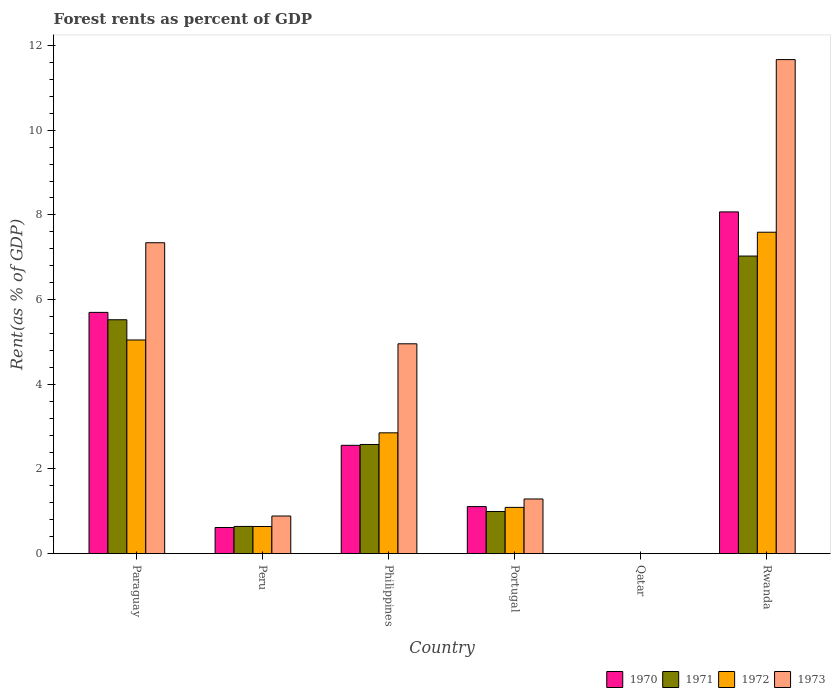How many different coloured bars are there?
Provide a succinct answer. 4. How many groups of bars are there?
Your response must be concise. 6. How many bars are there on the 4th tick from the right?
Provide a short and direct response. 4. What is the label of the 1st group of bars from the left?
Offer a very short reply. Paraguay. What is the forest rent in 1970 in Philippines?
Your answer should be very brief. 2.56. Across all countries, what is the maximum forest rent in 1973?
Keep it short and to the point. 11.67. Across all countries, what is the minimum forest rent in 1970?
Make the answer very short. 0. In which country was the forest rent in 1970 maximum?
Ensure brevity in your answer.  Rwanda. In which country was the forest rent in 1973 minimum?
Keep it short and to the point. Qatar. What is the total forest rent in 1970 in the graph?
Provide a short and direct response. 18.06. What is the difference between the forest rent in 1971 in Portugal and that in Rwanda?
Keep it short and to the point. -6.03. What is the difference between the forest rent in 1970 in Paraguay and the forest rent in 1973 in Rwanda?
Ensure brevity in your answer.  -5.97. What is the average forest rent in 1973 per country?
Keep it short and to the point. 4.36. What is the difference between the forest rent of/in 1970 and forest rent of/in 1973 in Philippines?
Offer a very short reply. -2.4. In how many countries, is the forest rent in 1972 greater than 6.8 %?
Give a very brief answer. 1. What is the ratio of the forest rent in 1972 in Philippines to that in Rwanda?
Ensure brevity in your answer.  0.38. What is the difference between the highest and the second highest forest rent in 1972?
Offer a terse response. -2.19. What is the difference between the highest and the lowest forest rent in 1970?
Provide a short and direct response. 8.07. What does the 3rd bar from the left in Rwanda represents?
Keep it short and to the point. 1972. What does the 4th bar from the right in Paraguay represents?
Provide a succinct answer. 1970. Are all the bars in the graph horizontal?
Keep it short and to the point. No. Are the values on the major ticks of Y-axis written in scientific E-notation?
Give a very brief answer. No. How many legend labels are there?
Offer a terse response. 4. What is the title of the graph?
Your answer should be compact. Forest rents as percent of GDP. What is the label or title of the Y-axis?
Give a very brief answer. Rent(as % of GDP). What is the Rent(as % of GDP) of 1970 in Paraguay?
Offer a terse response. 5.7. What is the Rent(as % of GDP) in 1971 in Paraguay?
Give a very brief answer. 5.52. What is the Rent(as % of GDP) of 1972 in Paraguay?
Make the answer very short. 5.05. What is the Rent(as % of GDP) in 1973 in Paraguay?
Your answer should be very brief. 7.34. What is the Rent(as % of GDP) of 1970 in Peru?
Ensure brevity in your answer.  0.62. What is the Rent(as % of GDP) in 1971 in Peru?
Provide a succinct answer. 0.64. What is the Rent(as % of GDP) of 1972 in Peru?
Keep it short and to the point. 0.64. What is the Rent(as % of GDP) of 1973 in Peru?
Your answer should be very brief. 0.89. What is the Rent(as % of GDP) in 1970 in Philippines?
Provide a succinct answer. 2.56. What is the Rent(as % of GDP) of 1971 in Philippines?
Provide a succinct answer. 2.58. What is the Rent(as % of GDP) of 1972 in Philippines?
Keep it short and to the point. 2.85. What is the Rent(as % of GDP) in 1973 in Philippines?
Offer a very short reply. 4.96. What is the Rent(as % of GDP) of 1970 in Portugal?
Offer a very short reply. 1.11. What is the Rent(as % of GDP) in 1971 in Portugal?
Your answer should be very brief. 1. What is the Rent(as % of GDP) in 1972 in Portugal?
Keep it short and to the point. 1.09. What is the Rent(as % of GDP) in 1973 in Portugal?
Provide a succinct answer. 1.29. What is the Rent(as % of GDP) of 1970 in Qatar?
Offer a very short reply. 0. What is the Rent(as % of GDP) in 1971 in Qatar?
Keep it short and to the point. 0. What is the Rent(as % of GDP) of 1972 in Qatar?
Provide a short and direct response. 0. What is the Rent(as % of GDP) of 1973 in Qatar?
Your answer should be compact. 0. What is the Rent(as % of GDP) in 1970 in Rwanda?
Provide a succinct answer. 8.07. What is the Rent(as % of GDP) of 1971 in Rwanda?
Provide a short and direct response. 7.03. What is the Rent(as % of GDP) of 1972 in Rwanda?
Keep it short and to the point. 7.59. What is the Rent(as % of GDP) in 1973 in Rwanda?
Provide a succinct answer. 11.67. Across all countries, what is the maximum Rent(as % of GDP) of 1970?
Give a very brief answer. 8.07. Across all countries, what is the maximum Rent(as % of GDP) of 1971?
Provide a short and direct response. 7.03. Across all countries, what is the maximum Rent(as % of GDP) of 1972?
Offer a very short reply. 7.59. Across all countries, what is the maximum Rent(as % of GDP) of 1973?
Make the answer very short. 11.67. Across all countries, what is the minimum Rent(as % of GDP) of 1970?
Give a very brief answer. 0. Across all countries, what is the minimum Rent(as % of GDP) of 1971?
Provide a succinct answer. 0. Across all countries, what is the minimum Rent(as % of GDP) of 1972?
Your response must be concise. 0. Across all countries, what is the minimum Rent(as % of GDP) of 1973?
Offer a terse response. 0. What is the total Rent(as % of GDP) of 1970 in the graph?
Your answer should be compact. 18.06. What is the total Rent(as % of GDP) of 1971 in the graph?
Ensure brevity in your answer.  16.77. What is the total Rent(as % of GDP) of 1972 in the graph?
Offer a very short reply. 17.23. What is the total Rent(as % of GDP) in 1973 in the graph?
Your answer should be compact. 26.15. What is the difference between the Rent(as % of GDP) in 1970 in Paraguay and that in Peru?
Provide a short and direct response. 5.08. What is the difference between the Rent(as % of GDP) in 1971 in Paraguay and that in Peru?
Your response must be concise. 4.88. What is the difference between the Rent(as % of GDP) in 1972 in Paraguay and that in Peru?
Offer a very short reply. 4.41. What is the difference between the Rent(as % of GDP) in 1973 in Paraguay and that in Peru?
Make the answer very short. 6.45. What is the difference between the Rent(as % of GDP) in 1970 in Paraguay and that in Philippines?
Provide a short and direct response. 3.14. What is the difference between the Rent(as % of GDP) in 1971 in Paraguay and that in Philippines?
Provide a short and direct response. 2.95. What is the difference between the Rent(as % of GDP) in 1972 in Paraguay and that in Philippines?
Offer a terse response. 2.19. What is the difference between the Rent(as % of GDP) in 1973 in Paraguay and that in Philippines?
Your answer should be very brief. 2.39. What is the difference between the Rent(as % of GDP) in 1970 in Paraguay and that in Portugal?
Offer a very short reply. 4.59. What is the difference between the Rent(as % of GDP) in 1971 in Paraguay and that in Portugal?
Your response must be concise. 4.53. What is the difference between the Rent(as % of GDP) of 1972 in Paraguay and that in Portugal?
Your answer should be very brief. 3.95. What is the difference between the Rent(as % of GDP) in 1973 in Paraguay and that in Portugal?
Give a very brief answer. 6.05. What is the difference between the Rent(as % of GDP) of 1970 in Paraguay and that in Qatar?
Make the answer very short. 5.7. What is the difference between the Rent(as % of GDP) in 1971 in Paraguay and that in Qatar?
Your answer should be compact. 5.52. What is the difference between the Rent(as % of GDP) in 1972 in Paraguay and that in Qatar?
Give a very brief answer. 5.05. What is the difference between the Rent(as % of GDP) in 1973 in Paraguay and that in Qatar?
Your response must be concise. 7.34. What is the difference between the Rent(as % of GDP) in 1970 in Paraguay and that in Rwanda?
Offer a very short reply. -2.37. What is the difference between the Rent(as % of GDP) of 1971 in Paraguay and that in Rwanda?
Your answer should be compact. -1.5. What is the difference between the Rent(as % of GDP) in 1972 in Paraguay and that in Rwanda?
Your response must be concise. -2.54. What is the difference between the Rent(as % of GDP) of 1973 in Paraguay and that in Rwanda?
Offer a very short reply. -4.33. What is the difference between the Rent(as % of GDP) in 1970 in Peru and that in Philippines?
Keep it short and to the point. -1.94. What is the difference between the Rent(as % of GDP) in 1971 in Peru and that in Philippines?
Provide a short and direct response. -1.94. What is the difference between the Rent(as % of GDP) in 1972 in Peru and that in Philippines?
Your response must be concise. -2.21. What is the difference between the Rent(as % of GDP) in 1973 in Peru and that in Philippines?
Provide a succinct answer. -4.07. What is the difference between the Rent(as % of GDP) of 1970 in Peru and that in Portugal?
Offer a very short reply. -0.49. What is the difference between the Rent(as % of GDP) of 1971 in Peru and that in Portugal?
Offer a terse response. -0.35. What is the difference between the Rent(as % of GDP) in 1972 in Peru and that in Portugal?
Give a very brief answer. -0.45. What is the difference between the Rent(as % of GDP) of 1973 in Peru and that in Portugal?
Your response must be concise. -0.4. What is the difference between the Rent(as % of GDP) of 1970 in Peru and that in Qatar?
Your response must be concise. 0.62. What is the difference between the Rent(as % of GDP) in 1971 in Peru and that in Qatar?
Give a very brief answer. 0.64. What is the difference between the Rent(as % of GDP) of 1972 in Peru and that in Qatar?
Your response must be concise. 0.64. What is the difference between the Rent(as % of GDP) of 1973 in Peru and that in Qatar?
Make the answer very short. 0.89. What is the difference between the Rent(as % of GDP) of 1970 in Peru and that in Rwanda?
Offer a terse response. -7.45. What is the difference between the Rent(as % of GDP) in 1971 in Peru and that in Rwanda?
Ensure brevity in your answer.  -6.39. What is the difference between the Rent(as % of GDP) of 1972 in Peru and that in Rwanda?
Your response must be concise. -6.95. What is the difference between the Rent(as % of GDP) of 1973 in Peru and that in Rwanda?
Your answer should be very brief. -10.78. What is the difference between the Rent(as % of GDP) in 1970 in Philippines and that in Portugal?
Give a very brief answer. 1.45. What is the difference between the Rent(as % of GDP) of 1971 in Philippines and that in Portugal?
Offer a terse response. 1.58. What is the difference between the Rent(as % of GDP) of 1972 in Philippines and that in Portugal?
Keep it short and to the point. 1.76. What is the difference between the Rent(as % of GDP) of 1973 in Philippines and that in Portugal?
Your answer should be compact. 3.66. What is the difference between the Rent(as % of GDP) of 1970 in Philippines and that in Qatar?
Make the answer very short. 2.56. What is the difference between the Rent(as % of GDP) in 1971 in Philippines and that in Qatar?
Your answer should be very brief. 2.58. What is the difference between the Rent(as % of GDP) of 1972 in Philippines and that in Qatar?
Your response must be concise. 2.85. What is the difference between the Rent(as % of GDP) in 1973 in Philippines and that in Qatar?
Your response must be concise. 4.96. What is the difference between the Rent(as % of GDP) in 1970 in Philippines and that in Rwanda?
Offer a terse response. -5.51. What is the difference between the Rent(as % of GDP) in 1971 in Philippines and that in Rwanda?
Your response must be concise. -4.45. What is the difference between the Rent(as % of GDP) of 1972 in Philippines and that in Rwanda?
Make the answer very short. -4.74. What is the difference between the Rent(as % of GDP) in 1973 in Philippines and that in Rwanda?
Offer a very short reply. -6.71. What is the difference between the Rent(as % of GDP) in 1970 in Portugal and that in Qatar?
Provide a succinct answer. 1.11. What is the difference between the Rent(as % of GDP) of 1971 in Portugal and that in Qatar?
Ensure brevity in your answer.  1. What is the difference between the Rent(as % of GDP) of 1972 in Portugal and that in Qatar?
Make the answer very short. 1.09. What is the difference between the Rent(as % of GDP) of 1973 in Portugal and that in Qatar?
Keep it short and to the point. 1.29. What is the difference between the Rent(as % of GDP) of 1970 in Portugal and that in Rwanda?
Your response must be concise. -6.96. What is the difference between the Rent(as % of GDP) in 1971 in Portugal and that in Rwanda?
Your response must be concise. -6.03. What is the difference between the Rent(as % of GDP) in 1972 in Portugal and that in Rwanda?
Your answer should be compact. -6.5. What is the difference between the Rent(as % of GDP) of 1973 in Portugal and that in Rwanda?
Your answer should be very brief. -10.38. What is the difference between the Rent(as % of GDP) of 1970 in Qatar and that in Rwanda?
Your answer should be compact. -8.07. What is the difference between the Rent(as % of GDP) of 1971 in Qatar and that in Rwanda?
Offer a very short reply. -7.03. What is the difference between the Rent(as % of GDP) in 1972 in Qatar and that in Rwanda?
Provide a short and direct response. -7.59. What is the difference between the Rent(as % of GDP) in 1973 in Qatar and that in Rwanda?
Your answer should be compact. -11.67. What is the difference between the Rent(as % of GDP) of 1970 in Paraguay and the Rent(as % of GDP) of 1971 in Peru?
Give a very brief answer. 5.06. What is the difference between the Rent(as % of GDP) of 1970 in Paraguay and the Rent(as % of GDP) of 1972 in Peru?
Provide a short and direct response. 5.06. What is the difference between the Rent(as % of GDP) of 1970 in Paraguay and the Rent(as % of GDP) of 1973 in Peru?
Keep it short and to the point. 4.81. What is the difference between the Rent(as % of GDP) in 1971 in Paraguay and the Rent(as % of GDP) in 1972 in Peru?
Provide a short and direct response. 4.88. What is the difference between the Rent(as % of GDP) in 1971 in Paraguay and the Rent(as % of GDP) in 1973 in Peru?
Offer a terse response. 4.64. What is the difference between the Rent(as % of GDP) in 1972 in Paraguay and the Rent(as % of GDP) in 1973 in Peru?
Your answer should be very brief. 4.16. What is the difference between the Rent(as % of GDP) in 1970 in Paraguay and the Rent(as % of GDP) in 1971 in Philippines?
Your answer should be compact. 3.12. What is the difference between the Rent(as % of GDP) of 1970 in Paraguay and the Rent(as % of GDP) of 1972 in Philippines?
Offer a terse response. 2.84. What is the difference between the Rent(as % of GDP) in 1970 in Paraguay and the Rent(as % of GDP) in 1973 in Philippines?
Give a very brief answer. 0.74. What is the difference between the Rent(as % of GDP) of 1971 in Paraguay and the Rent(as % of GDP) of 1972 in Philippines?
Offer a very short reply. 2.67. What is the difference between the Rent(as % of GDP) in 1971 in Paraguay and the Rent(as % of GDP) in 1973 in Philippines?
Keep it short and to the point. 0.57. What is the difference between the Rent(as % of GDP) in 1972 in Paraguay and the Rent(as % of GDP) in 1973 in Philippines?
Ensure brevity in your answer.  0.09. What is the difference between the Rent(as % of GDP) in 1970 in Paraguay and the Rent(as % of GDP) in 1971 in Portugal?
Your response must be concise. 4.7. What is the difference between the Rent(as % of GDP) in 1970 in Paraguay and the Rent(as % of GDP) in 1972 in Portugal?
Keep it short and to the point. 4.61. What is the difference between the Rent(as % of GDP) of 1970 in Paraguay and the Rent(as % of GDP) of 1973 in Portugal?
Your answer should be compact. 4.41. What is the difference between the Rent(as % of GDP) in 1971 in Paraguay and the Rent(as % of GDP) in 1972 in Portugal?
Provide a short and direct response. 4.43. What is the difference between the Rent(as % of GDP) in 1971 in Paraguay and the Rent(as % of GDP) in 1973 in Portugal?
Ensure brevity in your answer.  4.23. What is the difference between the Rent(as % of GDP) of 1972 in Paraguay and the Rent(as % of GDP) of 1973 in Portugal?
Ensure brevity in your answer.  3.76. What is the difference between the Rent(as % of GDP) of 1970 in Paraguay and the Rent(as % of GDP) of 1971 in Qatar?
Provide a succinct answer. 5.7. What is the difference between the Rent(as % of GDP) of 1970 in Paraguay and the Rent(as % of GDP) of 1972 in Qatar?
Your response must be concise. 5.7. What is the difference between the Rent(as % of GDP) of 1970 in Paraguay and the Rent(as % of GDP) of 1973 in Qatar?
Offer a terse response. 5.7. What is the difference between the Rent(as % of GDP) in 1971 in Paraguay and the Rent(as % of GDP) in 1972 in Qatar?
Give a very brief answer. 5.52. What is the difference between the Rent(as % of GDP) in 1971 in Paraguay and the Rent(as % of GDP) in 1973 in Qatar?
Your response must be concise. 5.52. What is the difference between the Rent(as % of GDP) in 1972 in Paraguay and the Rent(as % of GDP) in 1973 in Qatar?
Offer a very short reply. 5.05. What is the difference between the Rent(as % of GDP) of 1970 in Paraguay and the Rent(as % of GDP) of 1971 in Rwanda?
Your answer should be very brief. -1.33. What is the difference between the Rent(as % of GDP) of 1970 in Paraguay and the Rent(as % of GDP) of 1972 in Rwanda?
Offer a terse response. -1.89. What is the difference between the Rent(as % of GDP) of 1970 in Paraguay and the Rent(as % of GDP) of 1973 in Rwanda?
Give a very brief answer. -5.97. What is the difference between the Rent(as % of GDP) in 1971 in Paraguay and the Rent(as % of GDP) in 1972 in Rwanda?
Your response must be concise. -2.07. What is the difference between the Rent(as % of GDP) of 1971 in Paraguay and the Rent(as % of GDP) of 1973 in Rwanda?
Make the answer very short. -6.14. What is the difference between the Rent(as % of GDP) in 1972 in Paraguay and the Rent(as % of GDP) in 1973 in Rwanda?
Your response must be concise. -6.62. What is the difference between the Rent(as % of GDP) in 1970 in Peru and the Rent(as % of GDP) in 1971 in Philippines?
Offer a very short reply. -1.96. What is the difference between the Rent(as % of GDP) in 1970 in Peru and the Rent(as % of GDP) in 1972 in Philippines?
Provide a short and direct response. -2.24. What is the difference between the Rent(as % of GDP) of 1970 in Peru and the Rent(as % of GDP) of 1973 in Philippines?
Provide a succinct answer. -4.34. What is the difference between the Rent(as % of GDP) in 1971 in Peru and the Rent(as % of GDP) in 1972 in Philippines?
Provide a succinct answer. -2.21. What is the difference between the Rent(as % of GDP) in 1971 in Peru and the Rent(as % of GDP) in 1973 in Philippines?
Give a very brief answer. -4.31. What is the difference between the Rent(as % of GDP) of 1972 in Peru and the Rent(as % of GDP) of 1973 in Philippines?
Provide a short and direct response. -4.31. What is the difference between the Rent(as % of GDP) of 1970 in Peru and the Rent(as % of GDP) of 1971 in Portugal?
Your response must be concise. -0.38. What is the difference between the Rent(as % of GDP) of 1970 in Peru and the Rent(as % of GDP) of 1972 in Portugal?
Your answer should be compact. -0.48. What is the difference between the Rent(as % of GDP) of 1970 in Peru and the Rent(as % of GDP) of 1973 in Portugal?
Provide a succinct answer. -0.67. What is the difference between the Rent(as % of GDP) of 1971 in Peru and the Rent(as % of GDP) of 1972 in Portugal?
Ensure brevity in your answer.  -0.45. What is the difference between the Rent(as % of GDP) in 1971 in Peru and the Rent(as % of GDP) in 1973 in Portugal?
Ensure brevity in your answer.  -0.65. What is the difference between the Rent(as % of GDP) of 1972 in Peru and the Rent(as % of GDP) of 1973 in Portugal?
Your response must be concise. -0.65. What is the difference between the Rent(as % of GDP) of 1970 in Peru and the Rent(as % of GDP) of 1971 in Qatar?
Provide a short and direct response. 0.62. What is the difference between the Rent(as % of GDP) of 1970 in Peru and the Rent(as % of GDP) of 1972 in Qatar?
Your answer should be very brief. 0.62. What is the difference between the Rent(as % of GDP) of 1970 in Peru and the Rent(as % of GDP) of 1973 in Qatar?
Provide a succinct answer. 0.62. What is the difference between the Rent(as % of GDP) of 1971 in Peru and the Rent(as % of GDP) of 1972 in Qatar?
Make the answer very short. 0.64. What is the difference between the Rent(as % of GDP) in 1971 in Peru and the Rent(as % of GDP) in 1973 in Qatar?
Provide a succinct answer. 0.64. What is the difference between the Rent(as % of GDP) in 1972 in Peru and the Rent(as % of GDP) in 1973 in Qatar?
Your answer should be very brief. 0.64. What is the difference between the Rent(as % of GDP) of 1970 in Peru and the Rent(as % of GDP) of 1971 in Rwanda?
Your response must be concise. -6.41. What is the difference between the Rent(as % of GDP) in 1970 in Peru and the Rent(as % of GDP) in 1972 in Rwanda?
Your response must be concise. -6.97. What is the difference between the Rent(as % of GDP) of 1970 in Peru and the Rent(as % of GDP) of 1973 in Rwanda?
Give a very brief answer. -11.05. What is the difference between the Rent(as % of GDP) in 1971 in Peru and the Rent(as % of GDP) in 1972 in Rwanda?
Your answer should be compact. -6.95. What is the difference between the Rent(as % of GDP) in 1971 in Peru and the Rent(as % of GDP) in 1973 in Rwanda?
Keep it short and to the point. -11.03. What is the difference between the Rent(as % of GDP) of 1972 in Peru and the Rent(as % of GDP) of 1973 in Rwanda?
Make the answer very short. -11.03. What is the difference between the Rent(as % of GDP) in 1970 in Philippines and the Rent(as % of GDP) in 1971 in Portugal?
Give a very brief answer. 1.56. What is the difference between the Rent(as % of GDP) in 1970 in Philippines and the Rent(as % of GDP) in 1972 in Portugal?
Offer a terse response. 1.47. What is the difference between the Rent(as % of GDP) in 1970 in Philippines and the Rent(as % of GDP) in 1973 in Portugal?
Make the answer very short. 1.27. What is the difference between the Rent(as % of GDP) of 1971 in Philippines and the Rent(as % of GDP) of 1972 in Portugal?
Your answer should be compact. 1.49. What is the difference between the Rent(as % of GDP) in 1971 in Philippines and the Rent(as % of GDP) in 1973 in Portugal?
Provide a short and direct response. 1.29. What is the difference between the Rent(as % of GDP) in 1972 in Philippines and the Rent(as % of GDP) in 1973 in Portugal?
Your answer should be very brief. 1.56. What is the difference between the Rent(as % of GDP) of 1970 in Philippines and the Rent(as % of GDP) of 1971 in Qatar?
Your answer should be compact. 2.56. What is the difference between the Rent(as % of GDP) of 1970 in Philippines and the Rent(as % of GDP) of 1972 in Qatar?
Offer a very short reply. 2.56. What is the difference between the Rent(as % of GDP) in 1970 in Philippines and the Rent(as % of GDP) in 1973 in Qatar?
Keep it short and to the point. 2.56. What is the difference between the Rent(as % of GDP) in 1971 in Philippines and the Rent(as % of GDP) in 1972 in Qatar?
Your answer should be very brief. 2.58. What is the difference between the Rent(as % of GDP) of 1971 in Philippines and the Rent(as % of GDP) of 1973 in Qatar?
Keep it short and to the point. 2.58. What is the difference between the Rent(as % of GDP) in 1972 in Philippines and the Rent(as % of GDP) in 1973 in Qatar?
Offer a terse response. 2.85. What is the difference between the Rent(as % of GDP) in 1970 in Philippines and the Rent(as % of GDP) in 1971 in Rwanda?
Keep it short and to the point. -4.47. What is the difference between the Rent(as % of GDP) in 1970 in Philippines and the Rent(as % of GDP) in 1972 in Rwanda?
Give a very brief answer. -5.03. What is the difference between the Rent(as % of GDP) of 1970 in Philippines and the Rent(as % of GDP) of 1973 in Rwanda?
Ensure brevity in your answer.  -9.11. What is the difference between the Rent(as % of GDP) of 1971 in Philippines and the Rent(as % of GDP) of 1972 in Rwanda?
Keep it short and to the point. -5.01. What is the difference between the Rent(as % of GDP) of 1971 in Philippines and the Rent(as % of GDP) of 1973 in Rwanda?
Give a very brief answer. -9.09. What is the difference between the Rent(as % of GDP) of 1972 in Philippines and the Rent(as % of GDP) of 1973 in Rwanda?
Provide a short and direct response. -8.81. What is the difference between the Rent(as % of GDP) of 1970 in Portugal and the Rent(as % of GDP) of 1971 in Qatar?
Provide a succinct answer. 1.11. What is the difference between the Rent(as % of GDP) in 1970 in Portugal and the Rent(as % of GDP) in 1972 in Qatar?
Offer a very short reply. 1.11. What is the difference between the Rent(as % of GDP) of 1970 in Portugal and the Rent(as % of GDP) of 1973 in Qatar?
Your answer should be compact. 1.11. What is the difference between the Rent(as % of GDP) of 1971 in Portugal and the Rent(as % of GDP) of 1972 in Qatar?
Give a very brief answer. 1. What is the difference between the Rent(as % of GDP) in 1971 in Portugal and the Rent(as % of GDP) in 1973 in Qatar?
Offer a very short reply. 0.99. What is the difference between the Rent(as % of GDP) in 1972 in Portugal and the Rent(as % of GDP) in 1973 in Qatar?
Provide a short and direct response. 1.09. What is the difference between the Rent(as % of GDP) of 1970 in Portugal and the Rent(as % of GDP) of 1971 in Rwanda?
Provide a short and direct response. -5.92. What is the difference between the Rent(as % of GDP) in 1970 in Portugal and the Rent(as % of GDP) in 1972 in Rwanda?
Ensure brevity in your answer.  -6.48. What is the difference between the Rent(as % of GDP) of 1970 in Portugal and the Rent(as % of GDP) of 1973 in Rwanda?
Keep it short and to the point. -10.56. What is the difference between the Rent(as % of GDP) in 1971 in Portugal and the Rent(as % of GDP) in 1972 in Rwanda?
Give a very brief answer. -6.6. What is the difference between the Rent(as % of GDP) in 1971 in Portugal and the Rent(as % of GDP) in 1973 in Rwanda?
Offer a terse response. -10.67. What is the difference between the Rent(as % of GDP) of 1972 in Portugal and the Rent(as % of GDP) of 1973 in Rwanda?
Your answer should be very brief. -10.58. What is the difference between the Rent(as % of GDP) of 1970 in Qatar and the Rent(as % of GDP) of 1971 in Rwanda?
Provide a short and direct response. -7.03. What is the difference between the Rent(as % of GDP) of 1970 in Qatar and the Rent(as % of GDP) of 1972 in Rwanda?
Your response must be concise. -7.59. What is the difference between the Rent(as % of GDP) of 1970 in Qatar and the Rent(as % of GDP) of 1973 in Rwanda?
Offer a very short reply. -11.67. What is the difference between the Rent(as % of GDP) in 1971 in Qatar and the Rent(as % of GDP) in 1972 in Rwanda?
Your answer should be very brief. -7.59. What is the difference between the Rent(as % of GDP) of 1971 in Qatar and the Rent(as % of GDP) of 1973 in Rwanda?
Provide a succinct answer. -11.67. What is the difference between the Rent(as % of GDP) of 1972 in Qatar and the Rent(as % of GDP) of 1973 in Rwanda?
Give a very brief answer. -11.67. What is the average Rent(as % of GDP) of 1970 per country?
Provide a short and direct response. 3.01. What is the average Rent(as % of GDP) of 1971 per country?
Your answer should be compact. 2.79. What is the average Rent(as % of GDP) of 1972 per country?
Ensure brevity in your answer.  2.87. What is the average Rent(as % of GDP) of 1973 per country?
Your answer should be compact. 4.36. What is the difference between the Rent(as % of GDP) of 1970 and Rent(as % of GDP) of 1971 in Paraguay?
Your response must be concise. 0.17. What is the difference between the Rent(as % of GDP) of 1970 and Rent(as % of GDP) of 1972 in Paraguay?
Provide a short and direct response. 0.65. What is the difference between the Rent(as % of GDP) in 1970 and Rent(as % of GDP) in 1973 in Paraguay?
Provide a short and direct response. -1.64. What is the difference between the Rent(as % of GDP) in 1971 and Rent(as % of GDP) in 1972 in Paraguay?
Offer a terse response. 0.48. What is the difference between the Rent(as % of GDP) in 1971 and Rent(as % of GDP) in 1973 in Paraguay?
Ensure brevity in your answer.  -1.82. What is the difference between the Rent(as % of GDP) of 1972 and Rent(as % of GDP) of 1973 in Paraguay?
Provide a short and direct response. -2.3. What is the difference between the Rent(as % of GDP) of 1970 and Rent(as % of GDP) of 1971 in Peru?
Offer a very short reply. -0.03. What is the difference between the Rent(as % of GDP) in 1970 and Rent(as % of GDP) in 1972 in Peru?
Offer a terse response. -0.02. What is the difference between the Rent(as % of GDP) in 1970 and Rent(as % of GDP) in 1973 in Peru?
Your answer should be very brief. -0.27. What is the difference between the Rent(as % of GDP) in 1971 and Rent(as % of GDP) in 1972 in Peru?
Provide a succinct answer. 0. What is the difference between the Rent(as % of GDP) in 1971 and Rent(as % of GDP) in 1973 in Peru?
Ensure brevity in your answer.  -0.25. What is the difference between the Rent(as % of GDP) of 1972 and Rent(as % of GDP) of 1973 in Peru?
Offer a very short reply. -0.25. What is the difference between the Rent(as % of GDP) in 1970 and Rent(as % of GDP) in 1971 in Philippines?
Give a very brief answer. -0.02. What is the difference between the Rent(as % of GDP) in 1970 and Rent(as % of GDP) in 1972 in Philippines?
Make the answer very short. -0.29. What is the difference between the Rent(as % of GDP) of 1970 and Rent(as % of GDP) of 1973 in Philippines?
Your answer should be very brief. -2.4. What is the difference between the Rent(as % of GDP) of 1971 and Rent(as % of GDP) of 1972 in Philippines?
Keep it short and to the point. -0.27. What is the difference between the Rent(as % of GDP) of 1971 and Rent(as % of GDP) of 1973 in Philippines?
Your response must be concise. -2.38. What is the difference between the Rent(as % of GDP) of 1972 and Rent(as % of GDP) of 1973 in Philippines?
Provide a succinct answer. -2.1. What is the difference between the Rent(as % of GDP) of 1970 and Rent(as % of GDP) of 1971 in Portugal?
Provide a succinct answer. 0.12. What is the difference between the Rent(as % of GDP) in 1970 and Rent(as % of GDP) in 1972 in Portugal?
Your answer should be compact. 0.02. What is the difference between the Rent(as % of GDP) of 1970 and Rent(as % of GDP) of 1973 in Portugal?
Keep it short and to the point. -0.18. What is the difference between the Rent(as % of GDP) of 1971 and Rent(as % of GDP) of 1972 in Portugal?
Offer a terse response. -0.1. What is the difference between the Rent(as % of GDP) of 1971 and Rent(as % of GDP) of 1973 in Portugal?
Ensure brevity in your answer.  -0.3. What is the difference between the Rent(as % of GDP) of 1972 and Rent(as % of GDP) of 1973 in Portugal?
Provide a succinct answer. -0.2. What is the difference between the Rent(as % of GDP) in 1970 and Rent(as % of GDP) in 1971 in Qatar?
Your answer should be very brief. 0. What is the difference between the Rent(as % of GDP) in 1970 and Rent(as % of GDP) in 1973 in Qatar?
Provide a short and direct response. 0. What is the difference between the Rent(as % of GDP) of 1971 and Rent(as % of GDP) of 1973 in Qatar?
Your response must be concise. -0. What is the difference between the Rent(as % of GDP) in 1972 and Rent(as % of GDP) in 1973 in Qatar?
Keep it short and to the point. -0. What is the difference between the Rent(as % of GDP) of 1970 and Rent(as % of GDP) of 1971 in Rwanda?
Give a very brief answer. 1.04. What is the difference between the Rent(as % of GDP) of 1970 and Rent(as % of GDP) of 1972 in Rwanda?
Give a very brief answer. 0.48. What is the difference between the Rent(as % of GDP) in 1970 and Rent(as % of GDP) in 1973 in Rwanda?
Offer a very short reply. -3.6. What is the difference between the Rent(as % of GDP) in 1971 and Rent(as % of GDP) in 1972 in Rwanda?
Give a very brief answer. -0.56. What is the difference between the Rent(as % of GDP) in 1971 and Rent(as % of GDP) in 1973 in Rwanda?
Make the answer very short. -4.64. What is the difference between the Rent(as % of GDP) in 1972 and Rent(as % of GDP) in 1973 in Rwanda?
Give a very brief answer. -4.08. What is the ratio of the Rent(as % of GDP) of 1970 in Paraguay to that in Peru?
Provide a succinct answer. 9.23. What is the ratio of the Rent(as % of GDP) in 1971 in Paraguay to that in Peru?
Make the answer very short. 8.59. What is the ratio of the Rent(as % of GDP) in 1972 in Paraguay to that in Peru?
Your answer should be very brief. 7.87. What is the ratio of the Rent(as % of GDP) of 1973 in Paraguay to that in Peru?
Ensure brevity in your answer.  8.26. What is the ratio of the Rent(as % of GDP) in 1970 in Paraguay to that in Philippines?
Offer a very short reply. 2.23. What is the ratio of the Rent(as % of GDP) of 1971 in Paraguay to that in Philippines?
Provide a short and direct response. 2.14. What is the ratio of the Rent(as % of GDP) of 1972 in Paraguay to that in Philippines?
Your answer should be very brief. 1.77. What is the ratio of the Rent(as % of GDP) in 1973 in Paraguay to that in Philippines?
Your response must be concise. 1.48. What is the ratio of the Rent(as % of GDP) of 1970 in Paraguay to that in Portugal?
Your answer should be compact. 5.13. What is the ratio of the Rent(as % of GDP) in 1971 in Paraguay to that in Portugal?
Give a very brief answer. 5.55. What is the ratio of the Rent(as % of GDP) in 1972 in Paraguay to that in Portugal?
Offer a very short reply. 4.62. What is the ratio of the Rent(as % of GDP) in 1973 in Paraguay to that in Portugal?
Provide a succinct answer. 5.69. What is the ratio of the Rent(as % of GDP) in 1970 in Paraguay to that in Qatar?
Ensure brevity in your answer.  5763.68. What is the ratio of the Rent(as % of GDP) of 1971 in Paraguay to that in Qatar?
Provide a short and direct response. 1.17e+04. What is the ratio of the Rent(as % of GDP) in 1972 in Paraguay to that in Qatar?
Provide a succinct answer. 1.13e+04. What is the ratio of the Rent(as % of GDP) of 1973 in Paraguay to that in Qatar?
Provide a short and direct response. 1.07e+04. What is the ratio of the Rent(as % of GDP) in 1970 in Paraguay to that in Rwanda?
Your answer should be compact. 0.71. What is the ratio of the Rent(as % of GDP) in 1971 in Paraguay to that in Rwanda?
Ensure brevity in your answer.  0.79. What is the ratio of the Rent(as % of GDP) in 1972 in Paraguay to that in Rwanda?
Your response must be concise. 0.66. What is the ratio of the Rent(as % of GDP) of 1973 in Paraguay to that in Rwanda?
Provide a succinct answer. 0.63. What is the ratio of the Rent(as % of GDP) of 1970 in Peru to that in Philippines?
Ensure brevity in your answer.  0.24. What is the ratio of the Rent(as % of GDP) in 1971 in Peru to that in Philippines?
Keep it short and to the point. 0.25. What is the ratio of the Rent(as % of GDP) of 1972 in Peru to that in Philippines?
Give a very brief answer. 0.22. What is the ratio of the Rent(as % of GDP) in 1973 in Peru to that in Philippines?
Provide a succinct answer. 0.18. What is the ratio of the Rent(as % of GDP) of 1970 in Peru to that in Portugal?
Your answer should be very brief. 0.56. What is the ratio of the Rent(as % of GDP) of 1971 in Peru to that in Portugal?
Give a very brief answer. 0.65. What is the ratio of the Rent(as % of GDP) in 1972 in Peru to that in Portugal?
Provide a short and direct response. 0.59. What is the ratio of the Rent(as % of GDP) of 1973 in Peru to that in Portugal?
Provide a succinct answer. 0.69. What is the ratio of the Rent(as % of GDP) in 1970 in Peru to that in Qatar?
Your answer should be very brief. 624.78. What is the ratio of the Rent(as % of GDP) of 1971 in Peru to that in Qatar?
Make the answer very short. 1364.15. What is the ratio of the Rent(as % of GDP) in 1972 in Peru to that in Qatar?
Your answer should be compact. 1435.99. What is the ratio of the Rent(as % of GDP) of 1973 in Peru to that in Qatar?
Make the answer very short. 1296.36. What is the ratio of the Rent(as % of GDP) in 1970 in Peru to that in Rwanda?
Provide a short and direct response. 0.08. What is the ratio of the Rent(as % of GDP) of 1971 in Peru to that in Rwanda?
Make the answer very short. 0.09. What is the ratio of the Rent(as % of GDP) in 1972 in Peru to that in Rwanda?
Your answer should be very brief. 0.08. What is the ratio of the Rent(as % of GDP) in 1973 in Peru to that in Rwanda?
Provide a short and direct response. 0.08. What is the ratio of the Rent(as % of GDP) of 1970 in Philippines to that in Portugal?
Your answer should be very brief. 2.3. What is the ratio of the Rent(as % of GDP) of 1971 in Philippines to that in Portugal?
Give a very brief answer. 2.59. What is the ratio of the Rent(as % of GDP) in 1972 in Philippines to that in Portugal?
Make the answer very short. 2.61. What is the ratio of the Rent(as % of GDP) of 1973 in Philippines to that in Portugal?
Provide a short and direct response. 3.84. What is the ratio of the Rent(as % of GDP) of 1970 in Philippines to that in Qatar?
Offer a terse response. 2587.82. What is the ratio of the Rent(as % of GDP) of 1971 in Philippines to that in Qatar?
Your response must be concise. 5471.1. What is the ratio of the Rent(as % of GDP) of 1972 in Philippines to that in Qatar?
Keep it short and to the point. 6387.12. What is the ratio of the Rent(as % of GDP) in 1973 in Philippines to that in Qatar?
Make the answer very short. 7229.55. What is the ratio of the Rent(as % of GDP) in 1970 in Philippines to that in Rwanda?
Your answer should be compact. 0.32. What is the ratio of the Rent(as % of GDP) in 1971 in Philippines to that in Rwanda?
Offer a terse response. 0.37. What is the ratio of the Rent(as % of GDP) in 1972 in Philippines to that in Rwanda?
Your answer should be compact. 0.38. What is the ratio of the Rent(as % of GDP) of 1973 in Philippines to that in Rwanda?
Offer a terse response. 0.42. What is the ratio of the Rent(as % of GDP) in 1970 in Portugal to that in Qatar?
Give a very brief answer. 1124.35. What is the ratio of the Rent(as % of GDP) of 1971 in Portugal to that in Qatar?
Your answer should be very brief. 2112.66. What is the ratio of the Rent(as % of GDP) of 1972 in Portugal to that in Qatar?
Your response must be concise. 2446.62. What is the ratio of the Rent(as % of GDP) of 1973 in Portugal to that in Qatar?
Give a very brief answer. 1883.57. What is the ratio of the Rent(as % of GDP) of 1970 in Portugal to that in Rwanda?
Provide a short and direct response. 0.14. What is the ratio of the Rent(as % of GDP) of 1971 in Portugal to that in Rwanda?
Your response must be concise. 0.14. What is the ratio of the Rent(as % of GDP) of 1972 in Portugal to that in Rwanda?
Your answer should be very brief. 0.14. What is the ratio of the Rent(as % of GDP) in 1973 in Portugal to that in Rwanda?
Keep it short and to the point. 0.11. What is the ratio of the Rent(as % of GDP) in 1970 in Qatar to that in Rwanda?
Give a very brief answer. 0. What is the ratio of the Rent(as % of GDP) in 1971 in Qatar to that in Rwanda?
Your answer should be compact. 0. What is the difference between the highest and the second highest Rent(as % of GDP) in 1970?
Provide a succinct answer. 2.37. What is the difference between the highest and the second highest Rent(as % of GDP) of 1971?
Offer a very short reply. 1.5. What is the difference between the highest and the second highest Rent(as % of GDP) of 1972?
Keep it short and to the point. 2.54. What is the difference between the highest and the second highest Rent(as % of GDP) in 1973?
Provide a short and direct response. 4.33. What is the difference between the highest and the lowest Rent(as % of GDP) in 1970?
Offer a terse response. 8.07. What is the difference between the highest and the lowest Rent(as % of GDP) of 1971?
Offer a terse response. 7.03. What is the difference between the highest and the lowest Rent(as % of GDP) in 1972?
Your response must be concise. 7.59. What is the difference between the highest and the lowest Rent(as % of GDP) of 1973?
Offer a terse response. 11.67. 